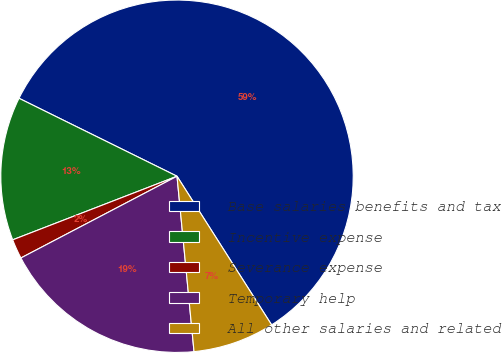Convert chart. <chart><loc_0><loc_0><loc_500><loc_500><pie_chart><fcel>Base salaries benefits and tax<fcel>Incentive expense<fcel>Severance expense<fcel>Temporary help<fcel>All other salaries and related<nl><fcel>58.68%<fcel>13.17%<fcel>1.8%<fcel>18.86%<fcel>7.48%<nl></chart> 